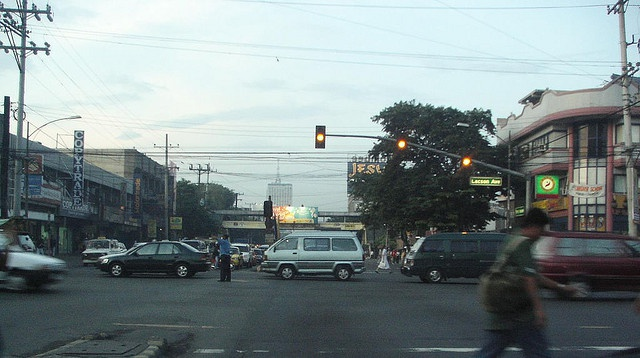Describe the objects in this image and their specific colors. I can see people in lightblue, black, gray, and purple tones, car in lightblue, black, and gray tones, car in lightblue, gray, black, and darkgray tones, car in lightblue, black, gray, purple, and darkblue tones, and car in lightblue, black, gray, and darkgray tones in this image. 